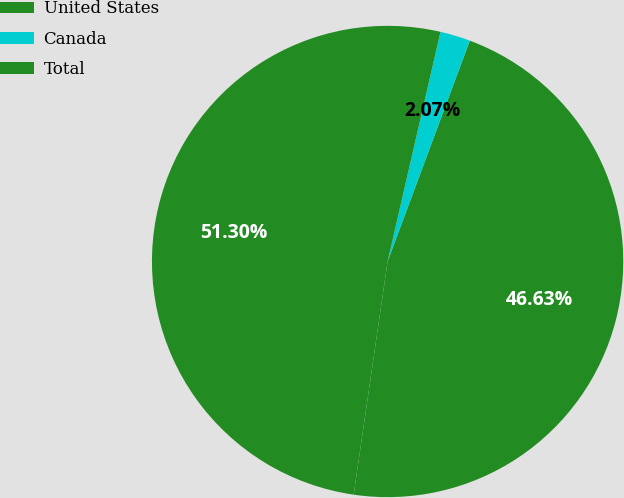Convert chart to OTSL. <chart><loc_0><loc_0><loc_500><loc_500><pie_chart><fcel>United States<fcel>Canada<fcel>Total<nl><fcel>46.63%<fcel>2.07%<fcel>51.3%<nl></chart> 